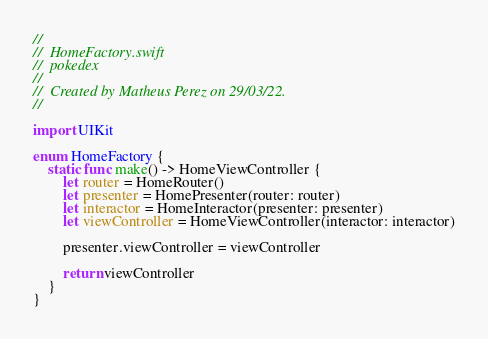<code> <loc_0><loc_0><loc_500><loc_500><_Swift_>//
//  HomeFactory.swift
//  pokedex
//
//  Created by Matheus Perez on 29/03/22.
//

import UIKit

enum HomeFactory {
    static func make() -> HomeViewController {
        let router = HomeRouter()
        let presenter = HomePresenter(router: router)
        let interactor = HomeInteractor(presenter: presenter)
        let viewController = HomeViewController(interactor: interactor)
        
        presenter.viewController = viewController
        
        return viewController
    }
}
</code> 